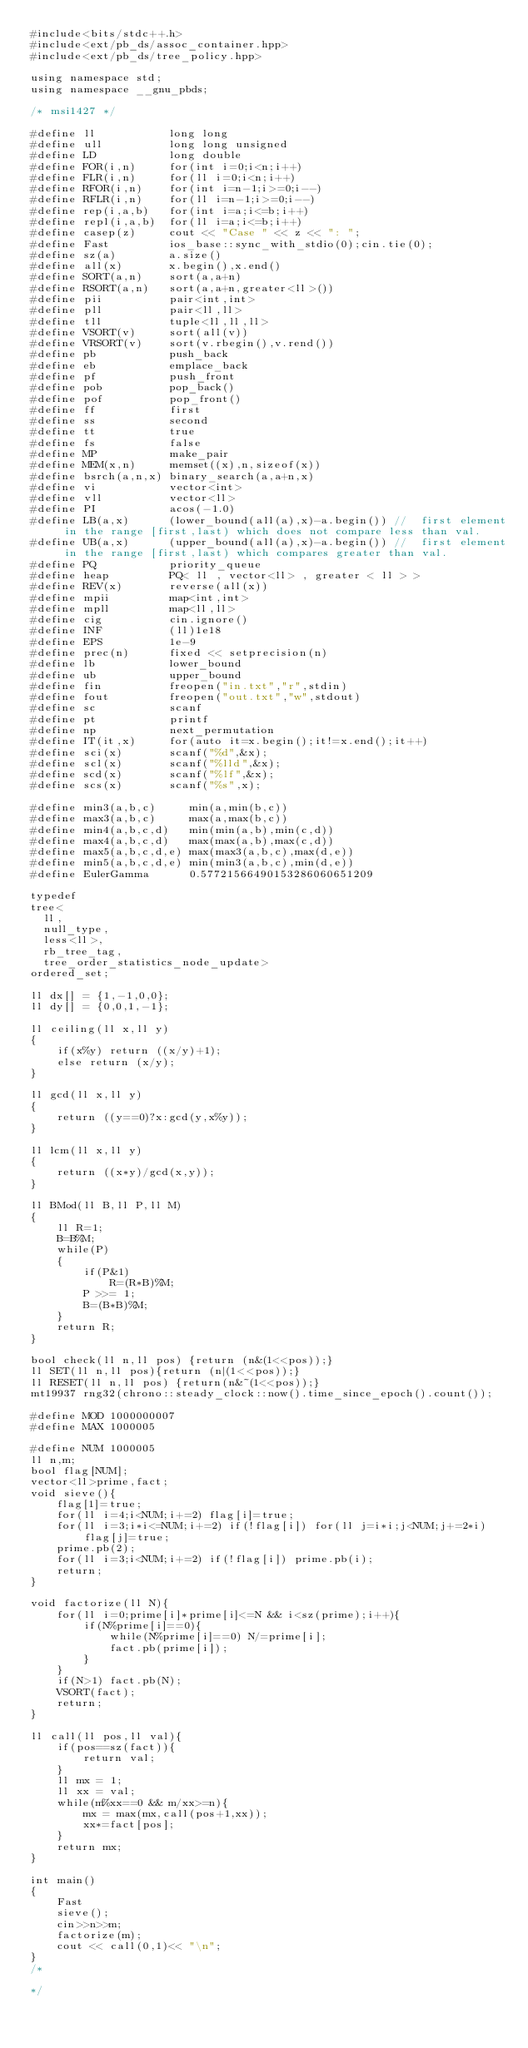Convert code to text. <code><loc_0><loc_0><loc_500><loc_500><_C++_>#include<bits/stdc++.h>
#include<ext/pb_ds/assoc_container.hpp>
#include<ext/pb_ds/tree_policy.hpp>

using namespace std;
using namespace __gnu_pbds;

/* msi1427 */

#define ll           long long
#define ull          long long unsigned
#define LD           long double
#define FOR(i,n)     for(int i=0;i<n;i++)
#define FLR(i,n)     for(ll i=0;i<n;i++)
#define RFOR(i,n)    for(int i=n-1;i>=0;i--)
#define RFLR(i,n)    for(ll i=n-1;i>=0;i--)
#define rep(i,a,b)   for(int i=a;i<=b;i++)
#define repl(i,a,b)  for(ll i=a;i<=b;i++)
#define casep(z)     cout << "Case " << z << ": ";
#define Fast         ios_base::sync_with_stdio(0);cin.tie(0);
#define sz(a)        a.size()
#define all(x)       x.begin(),x.end()
#define SORT(a,n)    sort(a,a+n)
#define RSORT(a,n)   sort(a,a+n,greater<ll>())
#define pii          pair<int,int>
#define pll          pair<ll,ll>
#define tll          tuple<ll,ll,ll>
#define VSORT(v)     sort(all(v))
#define VRSORT(v)    sort(v.rbegin(),v.rend())
#define pb           push_back
#define eb           emplace_back
#define pf           push_front
#define pob          pop_back()
#define pof          pop_front()
#define ff           first
#define ss           second
#define tt           true
#define fs           false
#define MP           make_pair
#define MEM(x,n)     memset((x),n,sizeof(x))
#define bsrch(a,n,x) binary_search(a,a+n,x)
#define vi           vector<int>
#define vll          vector<ll>
#define PI           acos(-1.0)
#define LB(a,x)      (lower_bound(all(a),x)-a.begin()) //  first element in the range [first,last) which does not compare less than val.
#define UB(a,x)      (upper_bound(all(a),x)-a.begin()) //  first element in the range [first,last) which compares greater than val.
#define PQ           priority_queue
#define heap         PQ< ll , vector<ll> , greater < ll > >
#define REV(x)       reverse(all(x))
#define mpii         map<int,int>
#define mpll         map<ll,ll>
#define cig          cin.ignore()
#define INF          (ll)1e18
#define EPS          1e-9
#define prec(n)      fixed << setprecision(n)
#define lb           lower_bound
#define ub           upper_bound
#define fin          freopen("in.txt","r",stdin)
#define fout         freopen("out.txt","w",stdout)
#define sc           scanf
#define pt           printf
#define np           next_permutation
#define IT(it,x)     for(auto it=x.begin();it!=x.end();it++)
#define sci(x)       scanf("%d",&x);
#define scl(x)       scanf("%lld",&x);
#define scd(x)       scanf("%lf",&x);
#define scs(x)       scanf("%s",x);

#define min3(a,b,c)     min(a,min(b,c))
#define max3(a,b,c)     max(a,max(b,c))
#define min4(a,b,c,d)   min(min(a,b),min(c,d))
#define max4(a,b,c,d)   max(max(a,b),max(c,d))
#define max5(a,b,c,d,e) max(max3(a,b,c),max(d,e))
#define min5(a,b,c,d,e) min(min3(a,b,c),min(d,e))
#define EulerGamma      0.57721566490153286060651209

typedef
tree<
  ll,
  null_type,
  less<ll>,
  rb_tree_tag,
  tree_order_statistics_node_update>
ordered_set;

ll dx[] = {1,-1,0,0};
ll dy[] = {0,0,1,-1};

ll ceiling(ll x,ll y)
{
    if(x%y) return ((x/y)+1);
    else return (x/y);
}

ll gcd(ll x,ll y)
{
    return ((y==0)?x:gcd(y,x%y));
}

ll lcm(ll x,ll y)
{
    return ((x*y)/gcd(x,y));
}

ll BMod(ll B,ll P,ll M)
{
    ll R=1;
    B=B%M;
    while(P)
    {
        if(P&1)
            R=(R*B)%M;
        P >>= 1;
        B=(B*B)%M;
    }
    return R;
}

bool check(ll n,ll pos) {return (n&(1<<pos));}
ll SET(ll n,ll pos){return (n|(1<<pos));}
ll RESET(ll n,ll pos) {return(n&~(1<<pos));}
mt19937 rng32(chrono::steady_clock::now().time_since_epoch().count());

#define MOD 1000000007
#define MAX 1000005

#define NUM 1000005
ll n,m;
bool flag[NUM];
vector<ll>prime,fact;
void sieve(){
    flag[1]=true;
    for(ll i=4;i<NUM;i+=2) flag[i]=true;
    for(ll i=3;i*i<=NUM;i+=2) if(!flag[i]) for(ll j=i*i;j<NUM;j+=2*i) flag[j]=true;
    prime.pb(2);
    for(ll i=3;i<NUM;i+=2) if(!flag[i]) prime.pb(i);
    return;
}

void factorize(ll N){
    for(ll i=0;prime[i]*prime[i]<=N && i<sz(prime);i++){
        if(N%prime[i]==0){
            while(N%prime[i]==0) N/=prime[i];
            fact.pb(prime[i]);
        }
    }
    if(N>1) fact.pb(N);
    VSORT(fact);
    return;
}

ll call(ll pos,ll val){
    if(pos==sz(fact)){
        return val;
    }
    ll mx = 1;
    ll xx = val;
    while(m%xx==0 && m/xx>=n){
        mx = max(mx,call(pos+1,xx));
        xx*=fact[pos];
    }
    return mx;
}

int main()
{
    Fast
    sieve();
    cin>>n>>m;
    factorize(m);
    cout << call(0,1)<< "\n";
}
/*

*/

</code> 